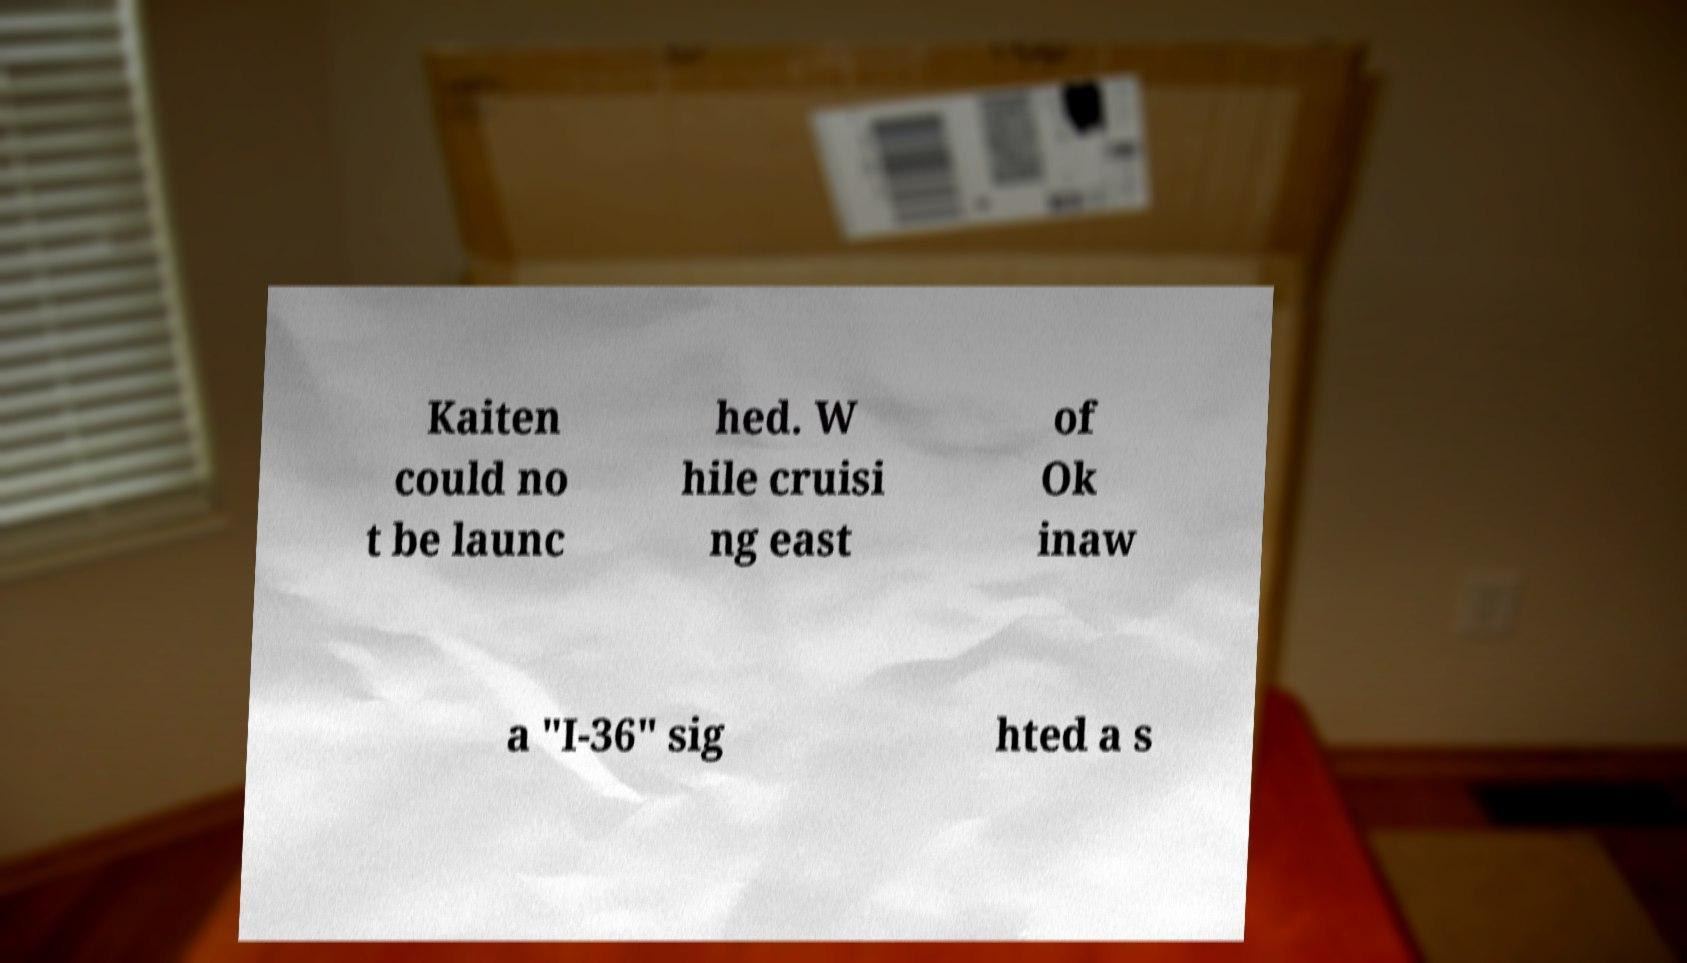Please identify and transcribe the text found in this image. Kaiten could no t be launc hed. W hile cruisi ng east of Ok inaw a "I-36" sig hted a s 